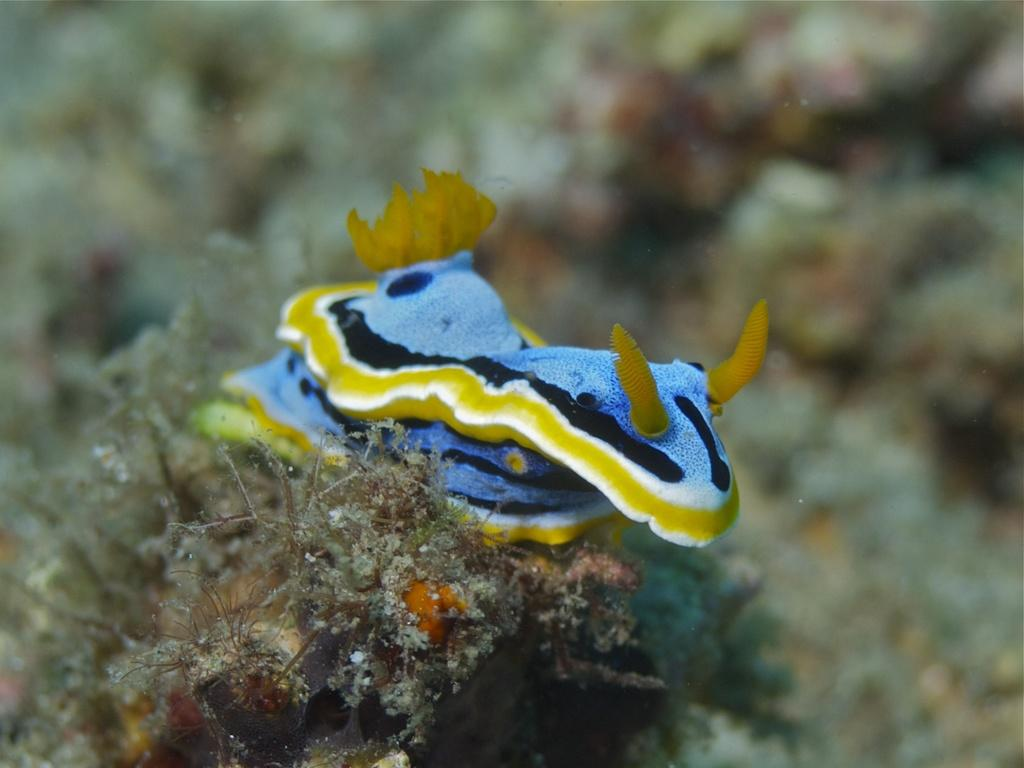What types of creatures are present in the image? There are sea animals in the image. What other living organism can be seen in the image? There is a plant in the image. Can you describe the background of the image? The background of the image is blurred. What type of structure is being protested in the image? There is no structure or protest present in the image; it features sea animals and a plant. Can you tell me how many dogs are visible in the image? There are no dogs present in the image. 